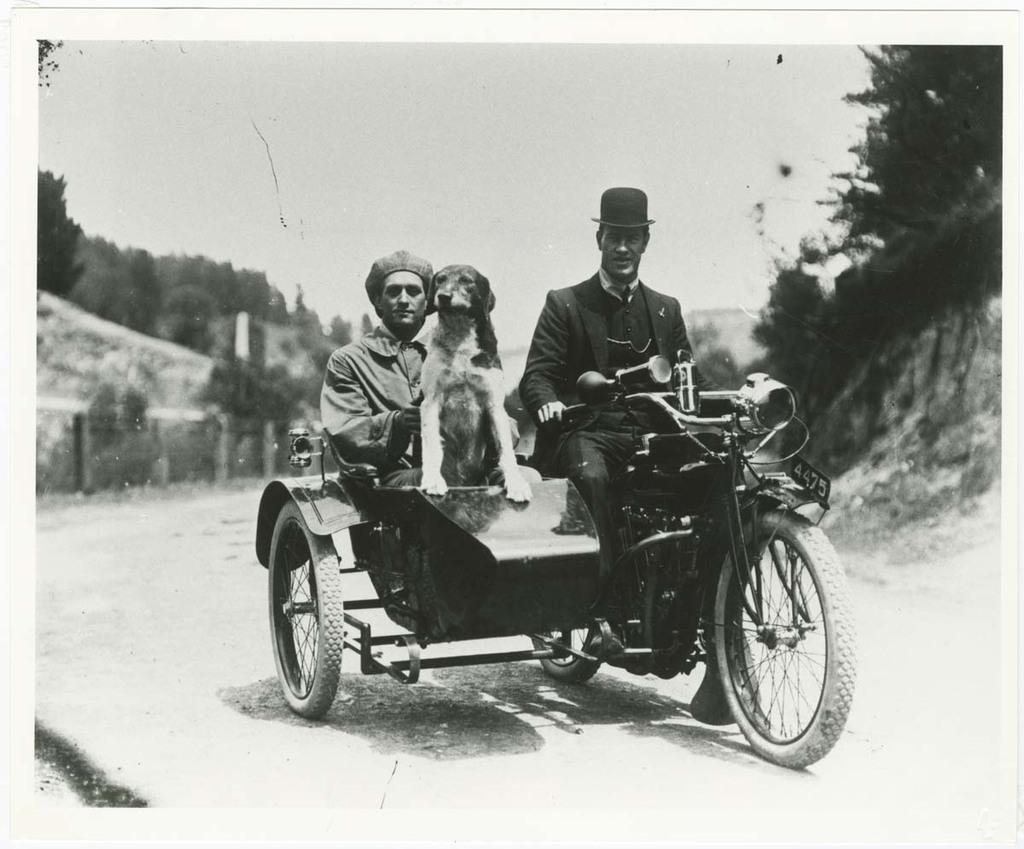How many people are in the image? There are two persons in the image. What other living creature is present in the image? There is a dog in the image. Where are the two persons and the dog located? They are sitting on a motorcycle. What type of surface are they on? They are on a path. What type of whistle can be heard in the image? There is no whistle present in the image, and therefore no sound can be heard. 